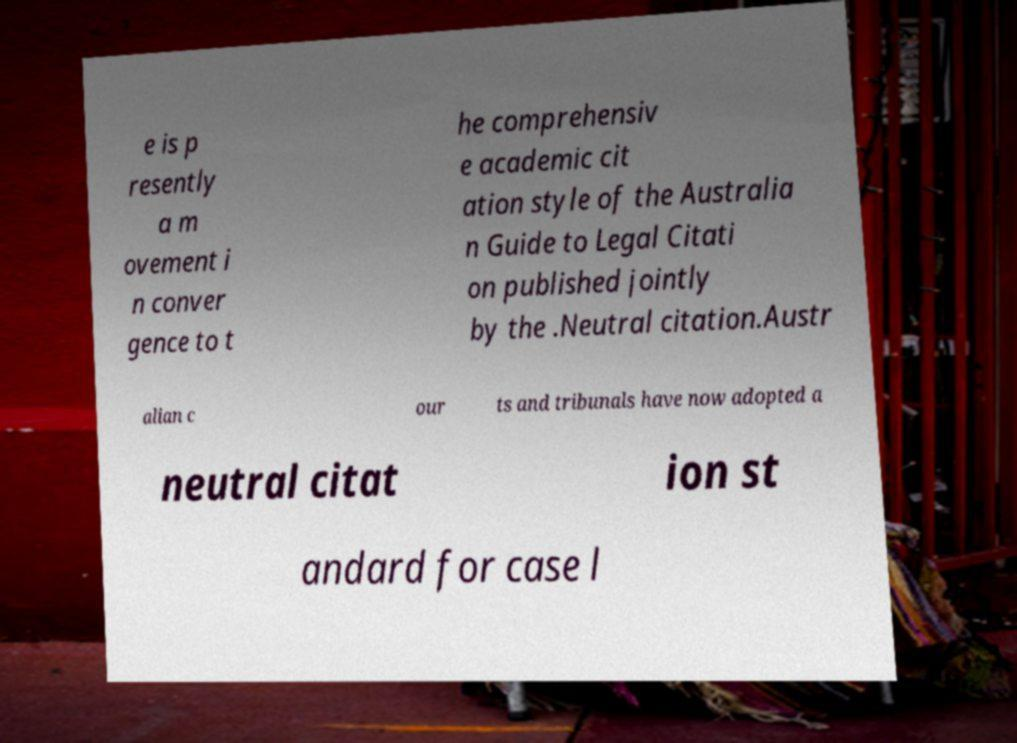Can you read and provide the text displayed in the image?This photo seems to have some interesting text. Can you extract and type it out for me? e is p resently a m ovement i n conver gence to t he comprehensiv e academic cit ation style of the Australia n Guide to Legal Citati on published jointly by the .Neutral citation.Austr alian c our ts and tribunals have now adopted a neutral citat ion st andard for case l 